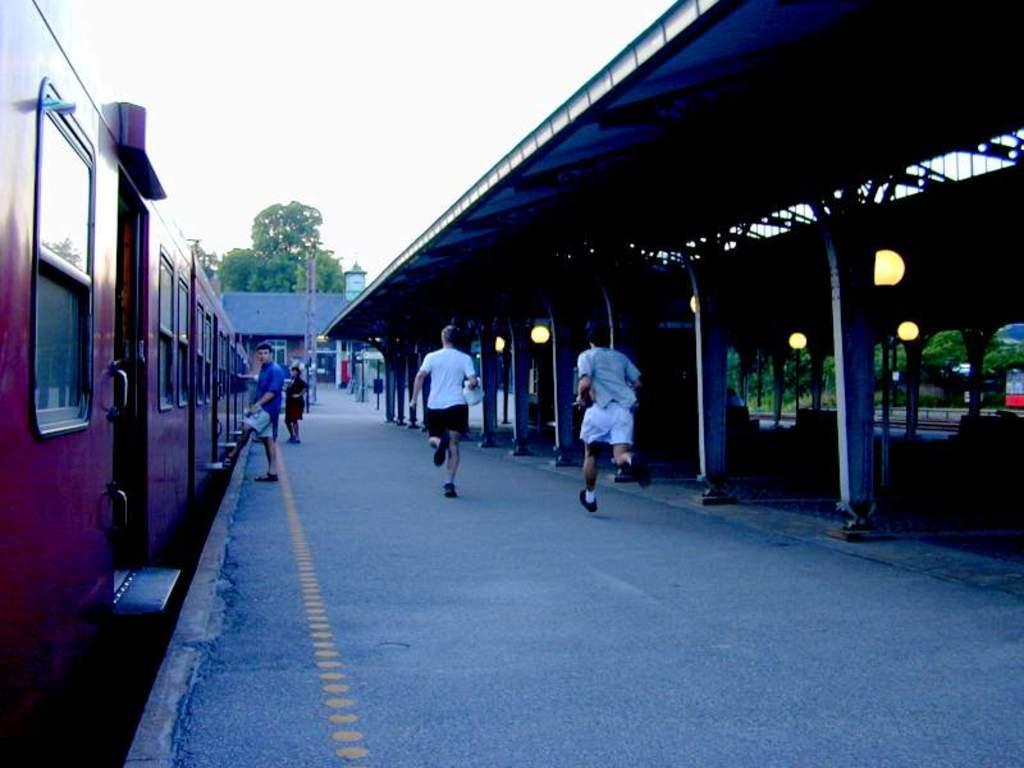Could you give a brief overview of what you see in this image? There is a train on the railway track near a platform. On which, there are two persons running and two persons standing. On the right side, there is a roof which is attached to the pillars which are on the floor. In the background, there is a building which is having roof, there are trees and there are clouds in the sky. 